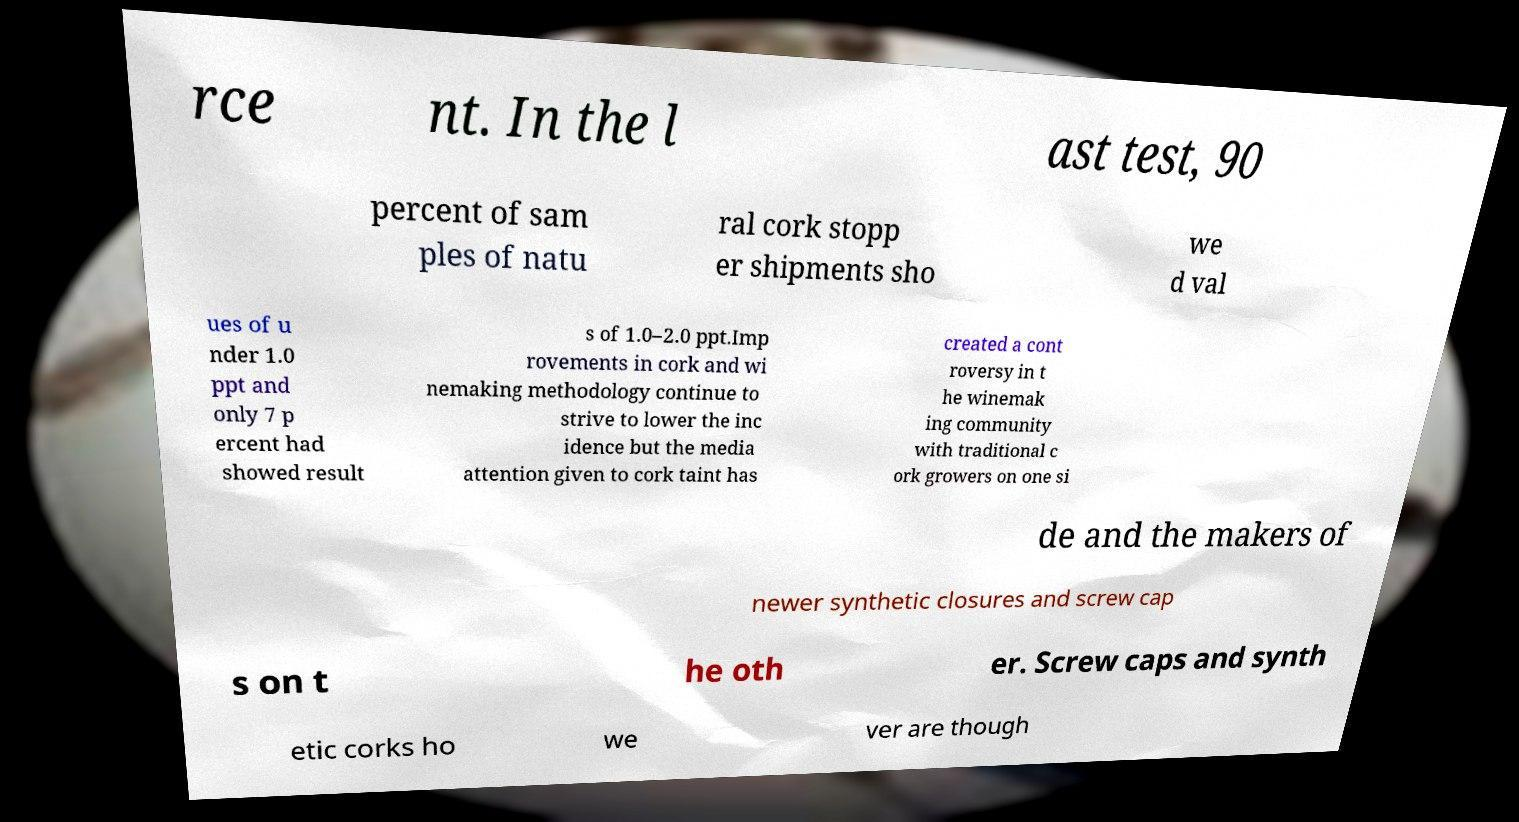For documentation purposes, I need the text within this image transcribed. Could you provide that? rce nt. In the l ast test, 90 percent of sam ples of natu ral cork stopp er shipments sho we d val ues of u nder 1.0 ppt and only 7 p ercent had showed result s of 1.0–2.0 ppt.Imp rovements in cork and wi nemaking methodology continue to strive to lower the inc idence but the media attention given to cork taint has created a cont roversy in t he winemak ing community with traditional c ork growers on one si de and the makers of newer synthetic closures and screw cap s on t he oth er. Screw caps and synth etic corks ho we ver are though 